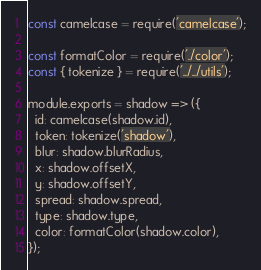Convert code to text. <code><loc_0><loc_0><loc_500><loc_500><_JavaScript_>const camelcase = require('camelcase');

const formatColor = require('./color');
const { tokenize } = require('../../utils');

module.exports = shadow => ({
  id: camelcase(shadow.id),
  token: tokenize('shadow'),
  blur: shadow.blurRadius,
  x: shadow.offsetX,
  y: shadow.offsetY,
  spread: shadow.spread,
  type: shadow.type,
  color: formatColor(shadow.color),
});
</code> 